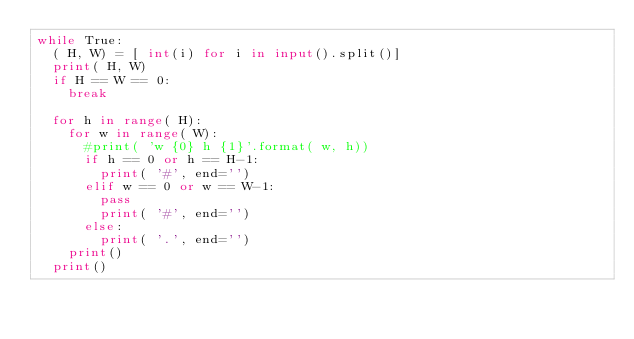Convert code to text. <code><loc_0><loc_0><loc_500><loc_500><_Python_>while True:
  ( H, W) = [ int(i) for i in input().split()]
  print( H, W)
  if H == W == 0:
    break

  for h in range( H):
    for w in range( W):
      #print( 'w {0} h {1}'.format( w, h))
      if h == 0 or h == H-1:
        print( '#', end='')
      elif w == 0 or w == W-1:
        pass
        print( '#', end='')
      else:
        print( '.', end='')
    print()
  print()</code> 